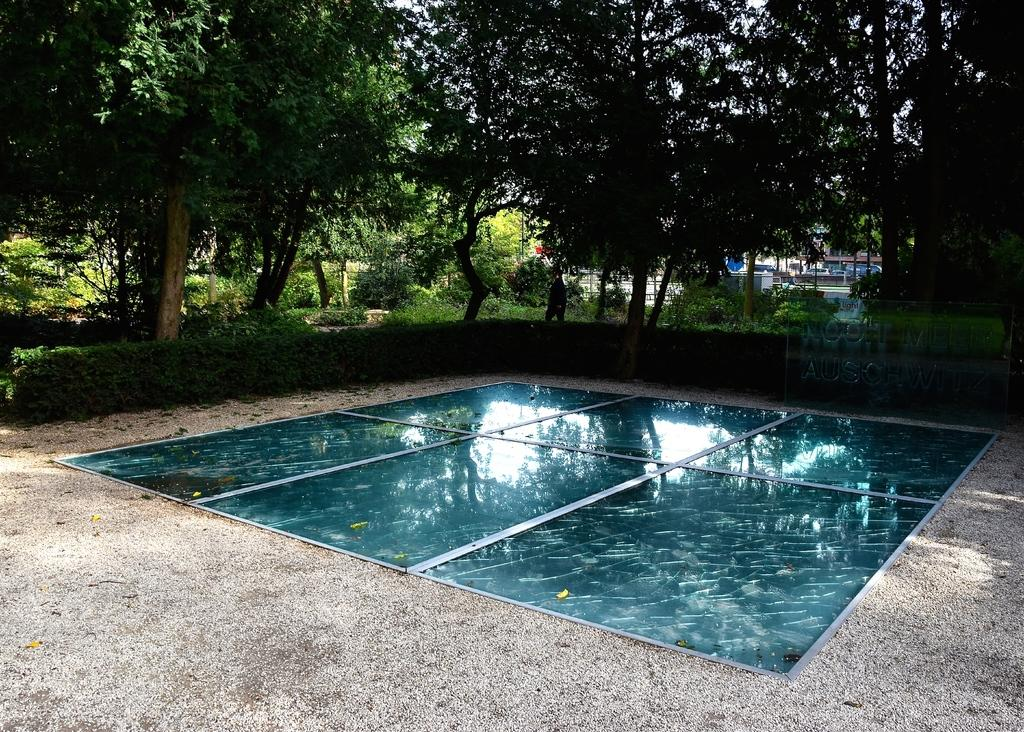Where was the picture taken? The picture was clicked outside. What is the main object in the center of the image? There is an object placed on the ground in the center of the image. What type of vegetation can be seen in the background of the image? There are plants, shrubs, and trees in the background of the image. What type of structures are visible in the background of the image? There are houses in the background of the image. What type of amusement park can be seen in the image? There is no amusement park present in the image. What type of polish is being applied to the object in the image? There is no polish or indication of any polishing activity in the image. 